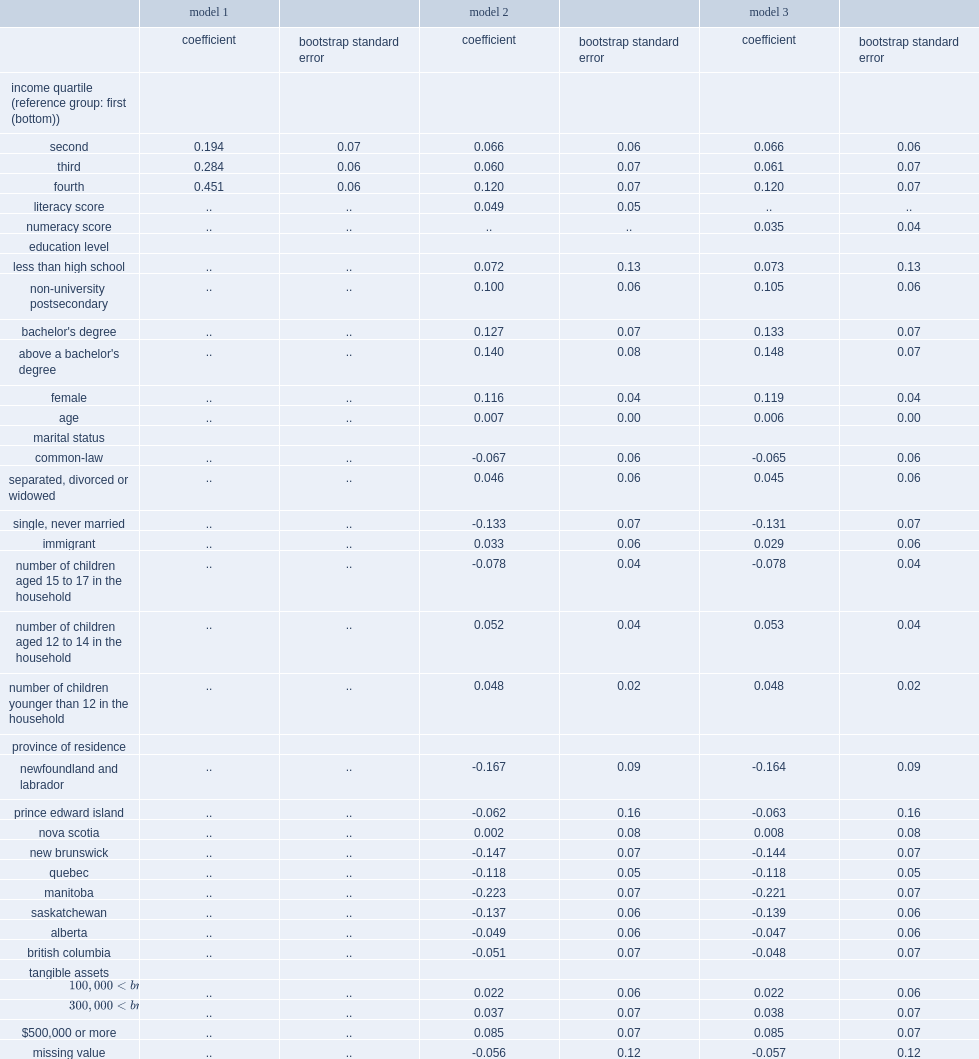How many percentage points increase in the probability of saving in an resp account was associated with a 100 point increase in the literacy score? 0.049. 